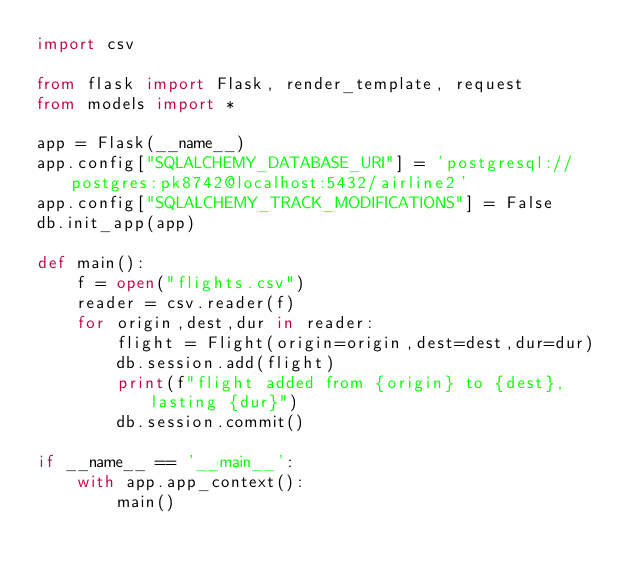<code> <loc_0><loc_0><loc_500><loc_500><_Python_>import csv

from flask import Flask, render_template, request
from models import *

app = Flask(__name__)
app.config["SQLALCHEMY_DATABASE_URI"] = 'postgresql://postgres:pk8742@localhost:5432/airline2'
app.config["SQLALCHEMY_TRACK_MODIFICATIONS"] = False
db.init_app(app)

def main():
    f = open("flights.csv")
    reader = csv.reader(f)
    for origin,dest,dur in reader:
        flight = Flight(origin=origin,dest=dest,dur=dur)
        db.session.add(flight)
        print(f"flight added from {origin} to {dest}, lasting {dur}")
        db.session.commit()

if __name__ == '__main__':
    with app.app_context():
        main()
</code> 